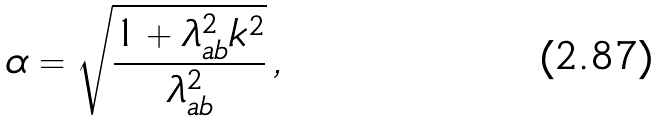<formula> <loc_0><loc_0><loc_500><loc_500>\alpha = \sqrt { \frac { 1 + \lambda _ { a b } ^ { 2 } k ^ { 2 } } { \lambda _ { a b } ^ { 2 } } } \, ,</formula> 